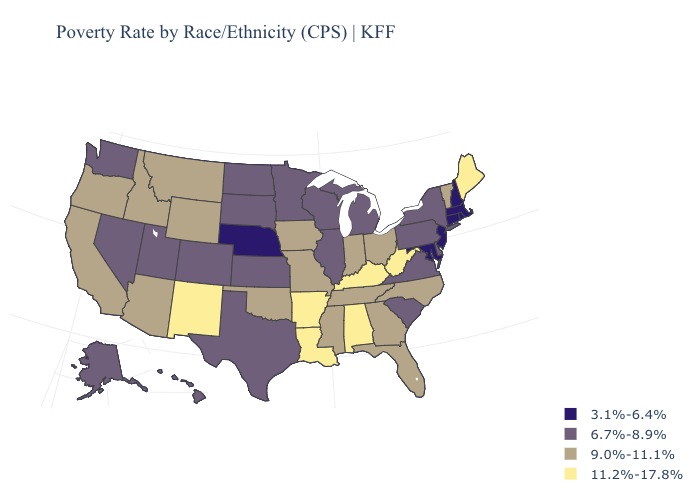What is the highest value in the South ?
Write a very short answer. 11.2%-17.8%. What is the value of Utah?
Short answer required. 6.7%-8.9%. What is the lowest value in states that border North Dakota?
Give a very brief answer. 6.7%-8.9%. What is the highest value in the MidWest ?
Be succinct. 9.0%-11.1%. Does Pennsylvania have the same value as Nevada?
Be succinct. Yes. Name the states that have a value in the range 9.0%-11.1%?
Quick response, please. Arizona, California, Florida, Georgia, Idaho, Indiana, Iowa, Mississippi, Missouri, Montana, North Carolina, Ohio, Oklahoma, Oregon, Tennessee, Vermont, Wyoming. What is the value of Michigan?
Short answer required. 6.7%-8.9%. Among the states that border New Mexico , which have the highest value?
Be succinct. Arizona, Oklahoma. Which states have the lowest value in the USA?
Write a very short answer. Connecticut, Maryland, Massachusetts, Nebraska, New Hampshire, New Jersey, Rhode Island. What is the value of New Mexico?
Quick response, please. 11.2%-17.8%. Does the first symbol in the legend represent the smallest category?
Concise answer only. Yes. Name the states that have a value in the range 11.2%-17.8%?
Short answer required. Alabama, Arkansas, Kentucky, Louisiana, Maine, New Mexico, West Virginia. Does South Dakota have the lowest value in the MidWest?
Concise answer only. No. What is the value of Michigan?
Give a very brief answer. 6.7%-8.9%. What is the value of Nevada?
Concise answer only. 6.7%-8.9%. 